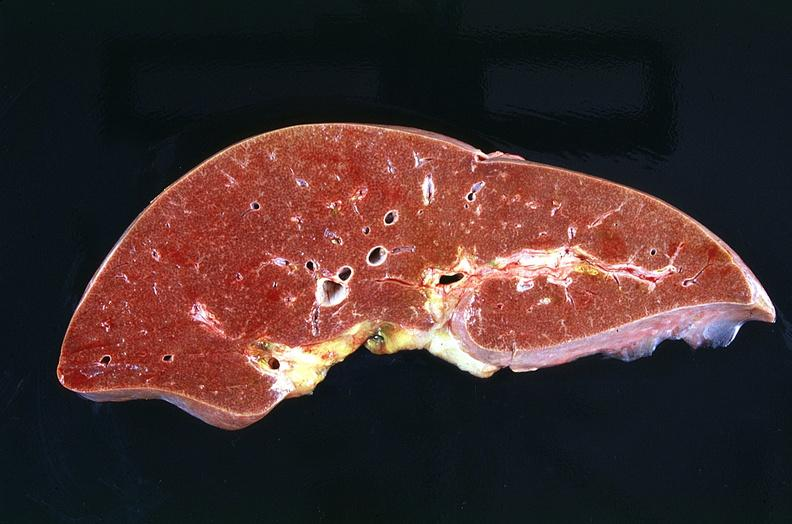does this image show liver, congestion and mild micronodular cirrhosis heart failure cirrhosis?
Answer the question using a single word or phrase. Yes 